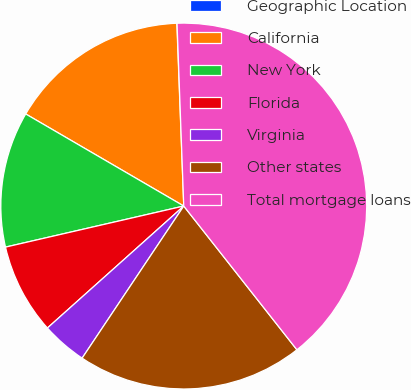<chart> <loc_0><loc_0><loc_500><loc_500><pie_chart><fcel>Geographic Location<fcel>California<fcel>New York<fcel>Florida<fcel>Virginia<fcel>Other states<fcel>Total mortgage loans<nl><fcel>0.02%<fcel>16.0%<fcel>12.0%<fcel>8.01%<fcel>4.01%<fcel>19.99%<fcel>39.97%<nl></chart> 